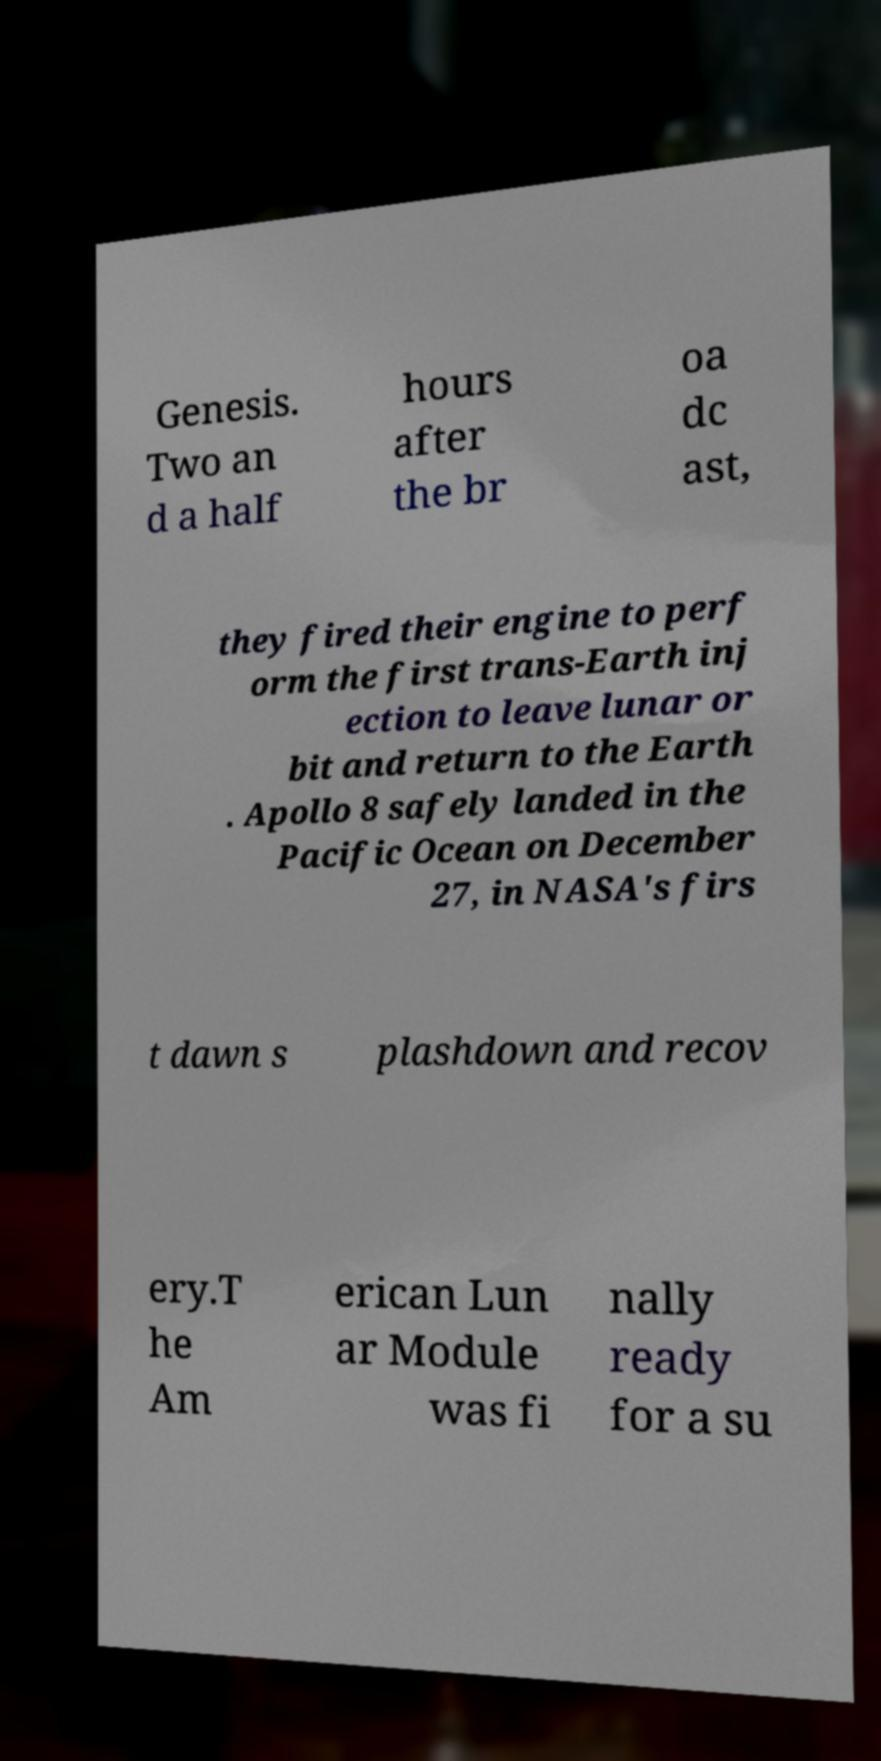There's text embedded in this image that I need extracted. Can you transcribe it verbatim? Genesis. Two an d a half hours after the br oa dc ast, they fired their engine to perf orm the first trans-Earth inj ection to leave lunar or bit and return to the Earth . Apollo 8 safely landed in the Pacific Ocean on December 27, in NASA's firs t dawn s plashdown and recov ery.T he Am erican Lun ar Module was fi nally ready for a su 